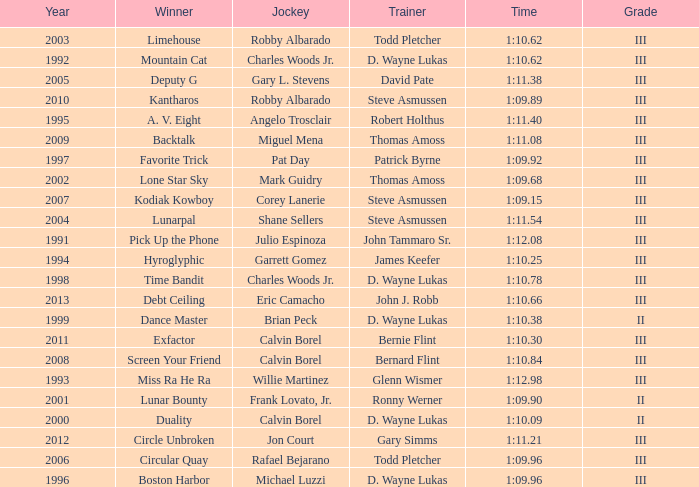Which trainer won the hyroglyphic in a year that was before 2010? James Keefer. 